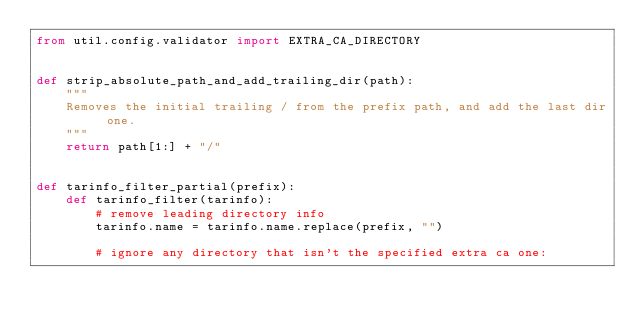<code> <loc_0><loc_0><loc_500><loc_500><_Python_>from util.config.validator import EXTRA_CA_DIRECTORY


def strip_absolute_path_and_add_trailing_dir(path):
    """
    Removes the initial trailing / from the prefix path, and add the last dir one.
    """
    return path[1:] + "/"


def tarinfo_filter_partial(prefix):
    def tarinfo_filter(tarinfo):
        # remove leading directory info
        tarinfo.name = tarinfo.name.replace(prefix, "")

        # ignore any directory that isn't the specified extra ca one:</code> 